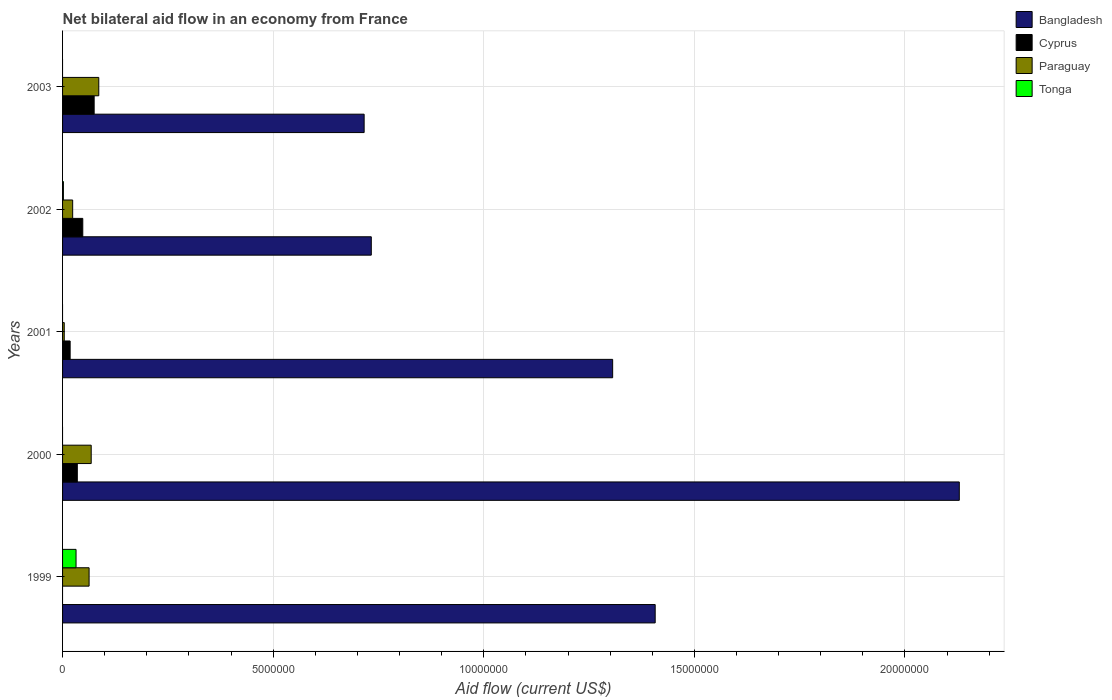How many different coloured bars are there?
Give a very brief answer. 4. Are the number of bars on each tick of the Y-axis equal?
Give a very brief answer. No. How many bars are there on the 2nd tick from the top?
Give a very brief answer. 4. How many bars are there on the 5th tick from the bottom?
Ensure brevity in your answer.  3. Across all years, what is the maximum net bilateral aid flow in Cyprus?
Your answer should be compact. 7.50e+05. Across all years, what is the minimum net bilateral aid flow in Cyprus?
Offer a terse response. 0. In which year was the net bilateral aid flow in Tonga maximum?
Offer a terse response. 1999. What is the total net bilateral aid flow in Bangladesh in the graph?
Ensure brevity in your answer.  6.29e+07. What is the difference between the net bilateral aid flow in Paraguay in 1999 and the net bilateral aid flow in Bangladesh in 2003?
Give a very brief answer. -6.53e+06. What is the average net bilateral aid flow in Cyprus per year?
Provide a short and direct response. 3.52e+05. What is the ratio of the net bilateral aid flow in Cyprus in 2000 to that in 2001?
Your answer should be very brief. 1.94. Is the net bilateral aid flow in Paraguay in 2001 less than that in 2003?
Your response must be concise. Yes. Is the difference between the net bilateral aid flow in Cyprus in 2000 and 2002 greater than the difference between the net bilateral aid flow in Paraguay in 2000 and 2002?
Give a very brief answer. No. What is the difference between the highest and the second highest net bilateral aid flow in Paraguay?
Make the answer very short. 1.80e+05. What is the difference between the highest and the lowest net bilateral aid flow in Cyprus?
Your answer should be very brief. 7.50e+05. Is it the case that in every year, the sum of the net bilateral aid flow in Paraguay and net bilateral aid flow in Bangladesh is greater than the sum of net bilateral aid flow in Cyprus and net bilateral aid flow in Tonga?
Offer a terse response. Yes. What is the difference between two consecutive major ticks on the X-axis?
Offer a terse response. 5.00e+06. Does the graph contain any zero values?
Your response must be concise. Yes. Where does the legend appear in the graph?
Your answer should be very brief. Top right. How many legend labels are there?
Make the answer very short. 4. What is the title of the graph?
Keep it short and to the point. Net bilateral aid flow in an economy from France. Does "Guyana" appear as one of the legend labels in the graph?
Give a very brief answer. No. What is the label or title of the X-axis?
Your answer should be very brief. Aid flow (current US$). What is the Aid flow (current US$) of Bangladesh in 1999?
Provide a short and direct response. 1.41e+07. What is the Aid flow (current US$) of Cyprus in 1999?
Give a very brief answer. 0. What is the Aid flow (current US$) of Paraguay in 1999?
Provide a succinct answer. 6.30e+05. What is the Aid flow (current US$) in Bangladesh in 2000?
Provide a succinct answer. 2.13e+07. What is the Aid flow (current US$) in Cyprus in 2000?
Your answer should be very brief. 3.50e+05. What is the Aid flow (current US$) of Paraguay in 2000?
Your answer should be very brief. 6.80e+05. What is the Aid flow (current US$) in Tonga in 2000?
Make the answer very short. 0. What is the Aid flow (current US$) in Bangladesh in 2001?
Your answer should be compact. 1.31e+07. What is the Aid flow (current US$) of Cyprus in 2001?
Your response must be concise. 1.80e+05. What is the Aid flow (current US$) in Paraguay in 2001?
Ensure brevity in your answer.  4.00e+04. What is the Aid flow (current US$) in Tonga in 2001?
Offer a terse response. 0. What is the Aid flow (current US$) of Bangladesh in 2002?
Offer a very short reply. 7.33e+06. What is the Aid flow (current US$) in Tonga in 2002?
Make the answer very short. 2.00e+04. What is the Aid flow (current US$) in Bangladesh in 2003?
Provide a short and direct response. 7.16e+06. What is the Aid flow (current US$) of Cyprus in 2003?
Your answer should be very brief. 7.50e+05. What is the Aid flow (current US$) of Paraguay in 2003?
Your response must be concise. 8.60e+05. Across all years, what is the maximum Aid flow (current US$) of Bangladesh?
Your response must be concise. 2.13e+07. Across all years, what is the maximum Aid flow (current US$) in Cyprus?
Keep it short and to the point. 7.50e+05. Across all years, what is the maximum Aid flow (current US$) in Paraguay?
Give a very brief answer. 8.60e+05. Across all years, what is the maximum Aid flow (current US$) in Tonga?
Give a very brief answer. 3.20e+05. Across all years, what is the minimum Aid flow (current US$) in Bangladesh?
Offer a terse response. 7.16e+06. Across all years, what is the minimum Aid flow (current US$) in Tonga?
Give a very brief answer. 0. What is the total Aid flow (current US$) of Bangladesh in the graph?
Ensure brevity in your answer.  6.29e+07. What is the total Aid flow (current US$) of Cyprus in the graph?
Make the answer very short. 1.76e+06. What is the total Aid flow (current US$) of Paraguay in the graph?
Your answer should be very brief. 2.45e+06. What is the difference between the Aid flow (current US$) in Bangladesh in 1999 and that in 2000?
Your answer should be compact. -7.22e+06. What is the difference between the Aid flow (current US$) of Paraguay in 1999 and that in 2000?
Make the answer very short. -5.00e+04. What is the difference between the Aid flow (current US$) in Bangladesh in 1999 and that in 2001?
Keep it short and to the point. 1.01e+06. What is the difference between the Aid flow (current US$) of Paraguay in 1999 and that in 2001?
Keep it short and to the point. 5.90e+05. What is the difference between the Aid flow (current US$) in Bangladesh in 1999 and that in 2002?
Your response must be concise. 6.74e+06. What is the difference between the Aid flow (current US$) of Paraguay in 1999 and that in 2002?
Give a very brief answer. 3.90e+05. What is the difference between the Aid flow (current US$) in Bangladesh in 1999 and that in 2003?
Make the answer very short. 6.91e+06. What is the difference between the Aid flow (current US$) of Paraguay in 1999 and that in 2003?
Keep it short and to the point. -2.30e+05. What is the difference between the Aid flow (current US$) in Bangladesh in 2000 and that in 2001?
Provide a succinct answer. 8.23e+06. What is the difference between the Aid flow (current US$) in Paraguay in 2000 and that in 2001?
Your answer should be very brief. 6.40e+05. What is the difference between the Aid flow (current US$) in Bangladesh in 2000 and that in 2002?
Your response must be concise. 1.40e+07. What is the difference between the Aid flow (current US$) of Cyprus in 2000 and that in 2002?
Give a very brief answer. -1.30e+05. What is the difference between the Aid flow (current US$) in Bangladesh in 2000 and that in 2003?
Offer a terse response. 1.41e+07. What is the difference between the Aid flow (current US$) of Cyprus in 2000 and that in 2003?
Provide a short and direct response. -4.00e+05. What is the difference between the Aid flow (current US$) of Paraguay in 2000 and that in 2003?
Your answer should be very brief. -1.80e+05. What is the difference between the Aid flow (current US$) of Bangladesh in 2001 and that in 2002?
Make the answer very short. 5.73e+06. What is the difference between the Aid flow (current US$) in Paraguay in 2001 and that in 2002?
Offer a terse response. -2.00e+05. What is the difference between the Aid flow (current US$) in Bangladesh in 2001 and that in 2003?
Make the answer very short. 5.90e+06. What is the difference between the Aid flow (current US$) in Cyprus in 2001 and that in 2003?
Ensure brevity in your answer.  -5.70e+05. What is the difference between the Aid flow (current US$) of Paraguay in 2001 and that in 2003?
Your answer should be compact. -8.20e+05. What is the difference between the Aid flow (current US$) of Bangladesh in 2002 and that in 2003?
Ensure brevity in your answer.  1.70e+05. What is the difference between the Aid flow (current US$) in Cyprus in 2002 and that in 2003?
Provide a succinct answer. -2.70e+05. What is the difference between the Aid flow (current US$) of Paraguay in 2002 and that in 2003?
Make the answer very short. -6.20e+05. What is the difference between the Aid flow (current US$) of Bangladesh in 1999 and the Aid flow (current US$) of Cyprus in 2000?
Keep it short and to the point. 1.37e+07. What is the difference between the Aid flow (current US$) in Bangladesh in 1999 and the Aid flow (current US$) in Paraguay in 2000?
Ensure brevity in your answer.  1.34e+07. What is the difference between the Aid flow (current US$) in Bangladesh in 1999 and the Aid flow (current US$) in Cyprus in 2001?
Your answer should be compact. 1.39e+07. What is the difference between the Aid flow (current US$) of Bangladesh in 1999 and the Aid flow (current US$) of Paraguay in 2001?
Your answer should be compact. 1.40e+07. What is the difference between the Aid flow (current US$) of Bangladesh in 1999 and the Aid flow (current US$) of Cyprus in 2002?
Provide a succinct answer. 1.36e+07. What is the difference between the Aid flow (current US$) in Bangladesh in 1999 and the Aid flow (current US$) in Paraguay in 2002?
Your answer should be compact. 1.38e+07. What is the difference between the Aid flow (current US$) of Bangladesh in 1999 and the Aid flow (current US$) of Tonga in 2002?
Ensure brevity in your answer.  1.40e+07. What is the difference between the Aid flow (current US$) of Bangladesh in 1999 and the Aid flow (current US$) of Cyprus in 2003?
Ensure brevity in your answer.  1.33e+07. What is the difference between the Aid flow (current US$) of Bangladesh in 1999 and the Aid flow (current US$) of Paraguay in 2003?
Provide a succinct answer. 1.32e+07. What is the difference between the Aid flow (current US$) in Bangladesh in 2000 and the Aid flow (current US$) in Cyprus in 2001?
Provide a short and direct response. 2.11e+07. What is the difference between the Aid flow (current US$) of Bangladesh in 2000 and the Aid flow (current US$) of Paraguay in 2001?
Make the answer very short. 2.12e+07. What is the difference between the Aid flow (current US$) of Cyprus in 2000 and the Aid flow (current US$) of Paraguay in 2001?
Provide a succinct answer. 3.10e+05. What is the difference between the Aid flow (current US$) in Bangladesh in 2000 and the Aid flow (current US$) in Cyprus in 2002?
Provide a succinct answer. 2.08e+07. What is the difference between the Aid flow (current US$) in Bangladesh in 2000 and the Aid flow (current US$) in Paraguay in 2002?
Give a very brief answer. 2.10e+07. What is the difference between the Aid flow (current US$) of Bangladesh in 2000 and the Aid flow (current US$) of Tonga in 2002?
Provide a short and direct response. 2.13e+07. What is the difference between the Aid flow (current US$) in Cyprus in 2000 and the Aid flow (current US$) in Tonga in 2002?
Give a very brief answer. 3.30e+05. What is the difference between the Aid flow (current US$) of Paraguay in 2000 and the Aid flow (current US$) of Tonga in 2002?
Give a very brief answer. 6.60e+05. What is the difference between the Aid flow (current US$) of Bangladesh in 2000 and the Aid flow (current US$) of Cyprus in 2003?
Make the answer very short. 2.05e+07. What is the difference between the Aid flow (current US$) in Bangladesh in 2000 and the Aid flow (current US$) in Paraguay in 2003?
Provide a succinct answer. 2.04e+07. What is the difference between the Aid flow (current US$) of Cyprus in 2000 and the Aid flow (current US$) of Paraguay in 2003?
Provide a succinct answer. -5.10e+05. What is the difference between the Aid flow (current US$) of Bangladesh in 2001 and the Aid flow (current US$) of Cyprus in 2002?
Your response must be concise. 1.26e+07. What is the difference between the Aid flow (current US$) of Bangladesh in 2001 and the Aid flow (current US$) of Paraguay in 2002?
Provide a succinct answer. 1.28e+07. What is the difference between the Aid flow (current US$) in Bangladesh in 2001 and the Aid flow (current US$) in Tonga in 2002?
Offer a terse response. 1.30e+07. What is the difference between the Aid flow (current US$) of Cyprus in 2001 and the Aid flow (current US$) of Paraguay in 2002?
Offer a terse response. -6.00e+04. What is the difference between the Aid flow (current US$) of Bangladesh in 2001 and the Aid flow (current US$) of Cyprus in 2003?
Your answer should be compact. 1.23e+07. What is the difference between the Aid flow (current US$) of Bangladesh in 2001 and the Aid flow (current US$) of Paraguay in 2003?
Your response must be concise. 1.22e+07. What is the difference between the Aid flow (current US$) in Cyprus in 2001 and the Aid flow (current US$) in Paraguay in 2003?
Your answer should be compact. -6.80e+05. What is the difference between the Aid flow (current US$) in Bangladesh in 2002 and the Aid flow (current US$) in Cyprus in 2003?
Your response must be concise. 6.58e+06. What is the difference between the Aid flow (current US$) of Bangladesh in 2002 and the Aid flow (current US$) of Paraguay in 2003?
Offer a very short reply. 6.47e+06. What is the difference between the Aid flow (current US$) of Cyprus in 2002 and the Aid flow (current US$) of Paraguay in 2003?
Make the answer very short. -3.80e+05. What is the average Aid flow (current US$) of Bangladesh per year?
Your response must be concise. 1.26e+07. What is the average Aid flow (current US$) in Cyprus per year?
Make the answer very short. 3.52e+05. What is the average Aid flow (current US$) of Tonga per year?
Your response must be concise. 6.80e+04. In the year 1999, what is the difference between the Aid flow (current US$) of Bangladesh and Aid flow (current US$) of Paraguay?
Give a very brief answer. 1.34e+07. In the year 1999, what is the difference between the Aid flow (current US$) in Bangladesh and Aid flow (current US$) in Tonga?
Offer a very short reply. 1.38e+07. In the year 2000, what is the difference between the Aid flow (current US$) in Bangladesh and Aid flow (current US$) in Cyprus?
Provide a succinct answer. 2.09e+07. In the year 2000, what is the difference between the Aid flow (current US$) in Bangladesh and Aid flow (current US$) in Paraguay?
Provide a succinct answer. 2.06e+07. In the year 2000, what is the difference between the Aid flow (current US$) in Cyprus and Aid flow (current US$) in Paraguay?
Offer a very short reply. -3.30e+05. In the year 2001, what is the difference between the Aid flow (current US$) of Bangladesh and Aid flow (current US$) of Cyprus?
Provide a succinct answer. 1.29e+07. In the year 2001, what is the difference between the Aid flow (current US$) in Bangladesh and Aid flow (current US$) in Paraguay?
Ensure brevity in your answer.  1.30e+07. In the year 2002, what is the difference between the Aid flow (current US$) of Bangladesh and Aid flow (current US$) of Cyprus?
Offer a terse response. 6.85e+06. In the year 2002, what is the difference between the Aid flow (current US$) in Bangladesh and Aid flow (current US$) in Paraguay?
Offer a terse response. 7.09e+06. In the year 2002, what is the difference between the Aid flow (current US$) of Bangladesh and Aid flow (current US$) of Tonga?
Ensure brevity in your answer.  7.31e+06. In the year 2002, what is the difference between the Aid flow (current US$) of Cyprus and Aid flow (current US$) of Paraguay?
Make the answer very short. 2.40e+05. In the year 2003, what is the difference between the Aid flow (current US$) of Bangladesh and Aid flow (current US$) of Cyprus?
Make the answer very short. 6.41e+06. In the year 2003, what is the difference between the Aid flow (current US$) of Bangladesh and Aid flow (current US$) of Paraguay?
Your response must be concise. 6.30e+06. What is the ratio of the Aid flow (current US$) of Bangladesh in 1999 to that in 2000?
Make the answer very short. 0.66. What is the ratio of the Aid flow (current US$) in Paraguay in 1999 to that in 2000?
Your response must be concise. 0.93. What is the ratio of the Aid flow (current US$) of Bangladesh in 1999 to that in 2001?
Your answer should be very brief. 1.08. What is the ratio of the Aid flow (current US$) in Paraguay in 1999 to that in 2001?
Your answer should be very brief. 15.75. What is the ratio of the Aid flow (current US$) of Bangladesh in 1999 to that in 2002?
Your response must be concise. 1.92. What is the ratio of the Aid flow (current US$) of Paraguay in 1999 to that in 2002?
Your answer should be very brief. 2.62. What is the ratio of the Aid flow (current US$) of Bangladesh in 1999 to that in 2003?
Ensure brevity in your answer.  1.97. What is the ratio of the Aid flow (current US$) in Paraguay in 1999 to that in 2003?
Provide a short and direct response. 0.73. What is the ratio of the Aid flow (current US$) in Bangladesh in 2000 to that in 2001?
Make the answer very short. 1.63. What is the ratio of the Aid flow (current US$) in Cyprus in 2000 to that in 2001?
Give a very brief answer. 1.94. What is the ratio of the Aid flow (current US$) in Bangladesh in 2000 to that in 2002?
Provide a succinct answer. 2.9. What is the ratio of the Aid flow (current US$) in Cyprus in 2000 to that in 2002?
Your response must be concise. 0.73. What is the ratio of the Aid flow (current US$) in Paraguay in 2000 to that in 2002?
Keep it short and to the point. 2.83. What is the ratio of the Aid flow (current US$) of Bangladesh in 2000 to that in 2003?
Offer a terse response. 2.97. What is the ratio of the Aid flow (current US$) of Cyprus in 2000 to that in 2003?
Give a very brief answer. 0.47. What is the ratio of the Aid flow (current US$) of Paraguay in 2000 to that in 2003?
Provide a succinct answer. 0.79. What is the ratio of the Aid flow (current US$) of Bangladesh in 2001 to that in 2002?
Offer a terse response. 1.78. What is the ratio of the Aid flow (current US$) of Cyprus in 2001 to that in 2002?
Ensure brevity in your answer.  0.38. What is the ratio of the Aid flow (current US$) in Bangladesh in 2001 to that in 2003?
Provide a succinct answer. 1.82. What is the ratio of the Aid flow (current US$) in Cyprus in 2001 to that in 2003?
Make the answer very short. 0.24. What is the ratio of the Aid flow (current US$) in Paraguay in 2001 to that in 2003?
Offer a very short reply. 0.05. What is the ratio of the Aid flow (current US$) of Bangladesh in 2002 to that in 2003?
Provide a short and direct response. 1.02. What is the ratio of the Aid flow (current US$) of Cyprus in 2002 to that in 2003?
Your answer should be very brief. 0.64. What is the ratio of the Aid flow (current US$) of Paraguay in 2002 to that in 2003?
Your answer should be very brief. 0.28. What is the difference between the highest and the second highest Aid flow (current US$) in Bangladesh?
Make the answer very short. 7.22e+06. What is the difference between the highest and the second highest Aid flow (current US$) in Cyprus?
Your answer should be very brief. 2.70e+05. What is the difference between the highest and the lowest Aid flow (current US$) of Bangladesh?
Your response must be concise. 1.41e+07. What is the difference between the highest and the lowest Aid flow (current US$) in Cyprus?
Give a very brief answer. 7.50e+05. What is the difference between the highest and the lowest Aid flow (current US$) of Paraguay?
Your response must be concise. 8.20e+05. 